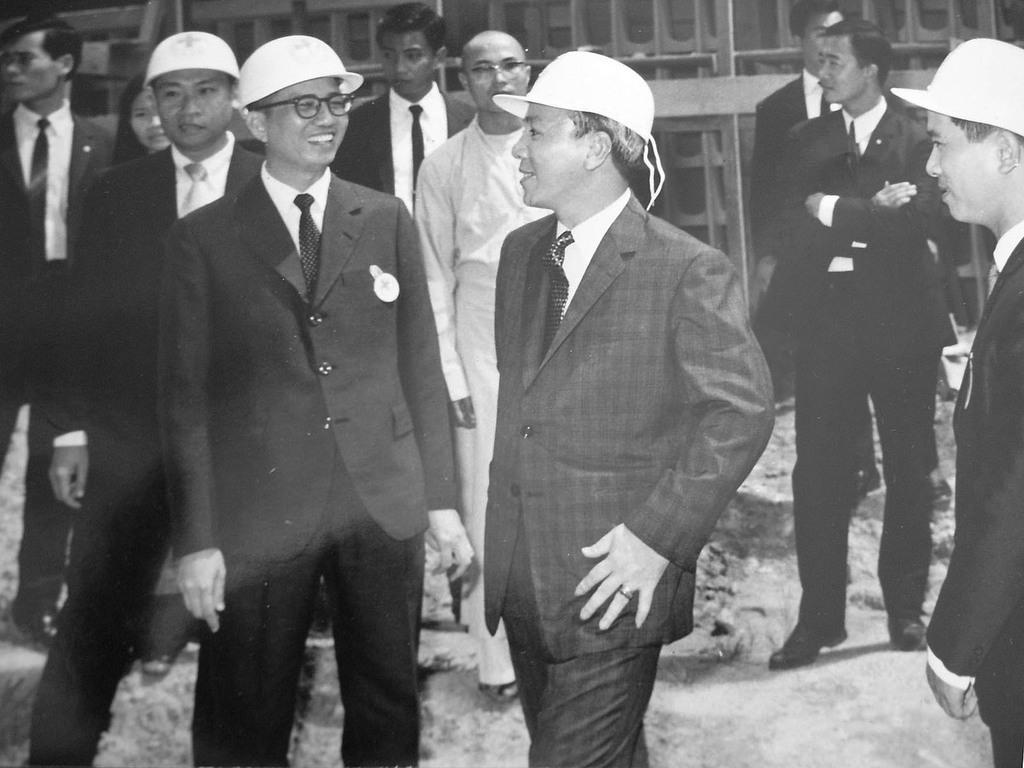How would you summarize this image in a sentence or two? It is a black and white picture. In the center of the image we can see a few people are standing and they are in different costumes. Among them, we can see a few people are smiling and a few people are wearing caps. In the background, we can see a few other objects. 